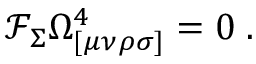Convert formula to latex. <formula><loc_0><loc_0><loc_500><loc_500>\mathcal { F } _ { \Sigma } \Omega _ { [ \mu \nu \rho \sigma ] } ^ { 4 } = 0 \, .</formula> 